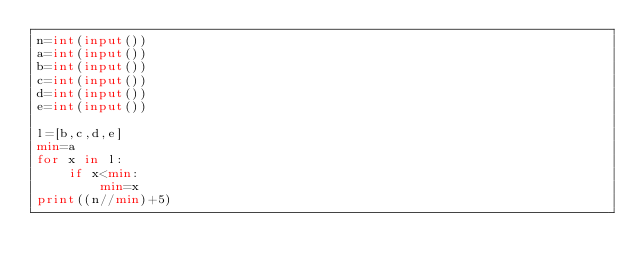<code> <loc_0><loc_0><loc_500><loc_500><_Python_>n=int(input())
a=int(input())
b=int(input())
c=int(input())
d=int(input())
e=int(input())

l=[b,c,d,e]
min=a
for x in l:
    if x<min:
        min=x
print((n//min)+5)</code> 